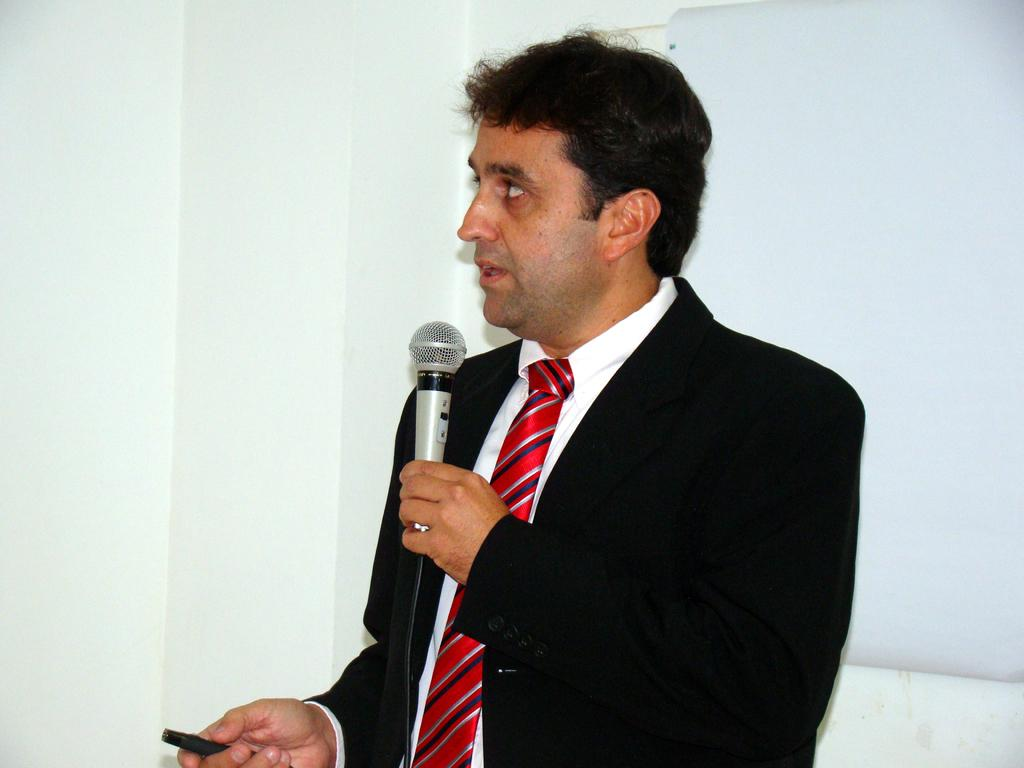What is the person in the image doing? The person is standing and talking into a microphone. What is the person wearing? The person is wearing a black suit and a red tie. What is the color of the background in the image? The background of the image is white. Where was the image taken? The image was taken inside a room. How many geese are visible in the image? There are no geese present in the image. What is the title of the speech being given by the person in the image? The provided facts do not mention the content or title of the speech, so we cannot determine that information from the image. 